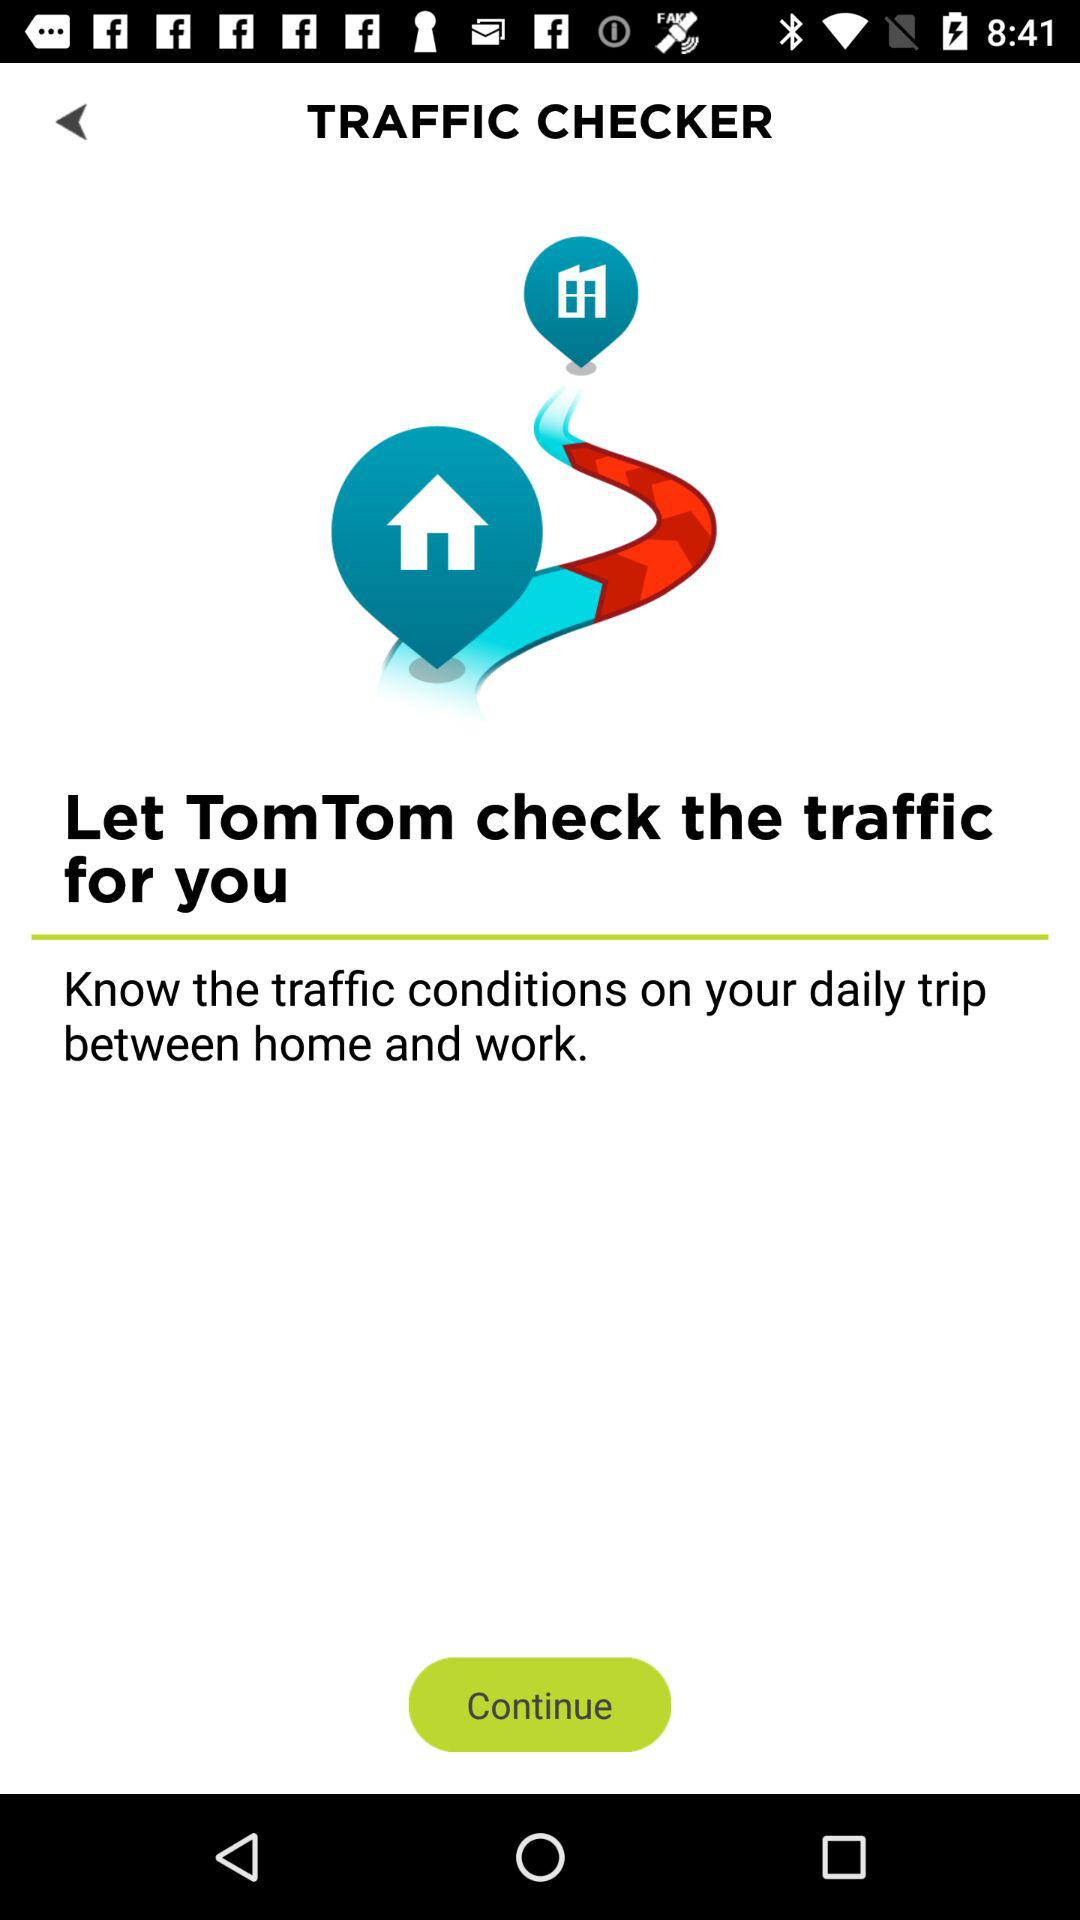Who checks the traffic? The traffic is checked by "TomTom". 